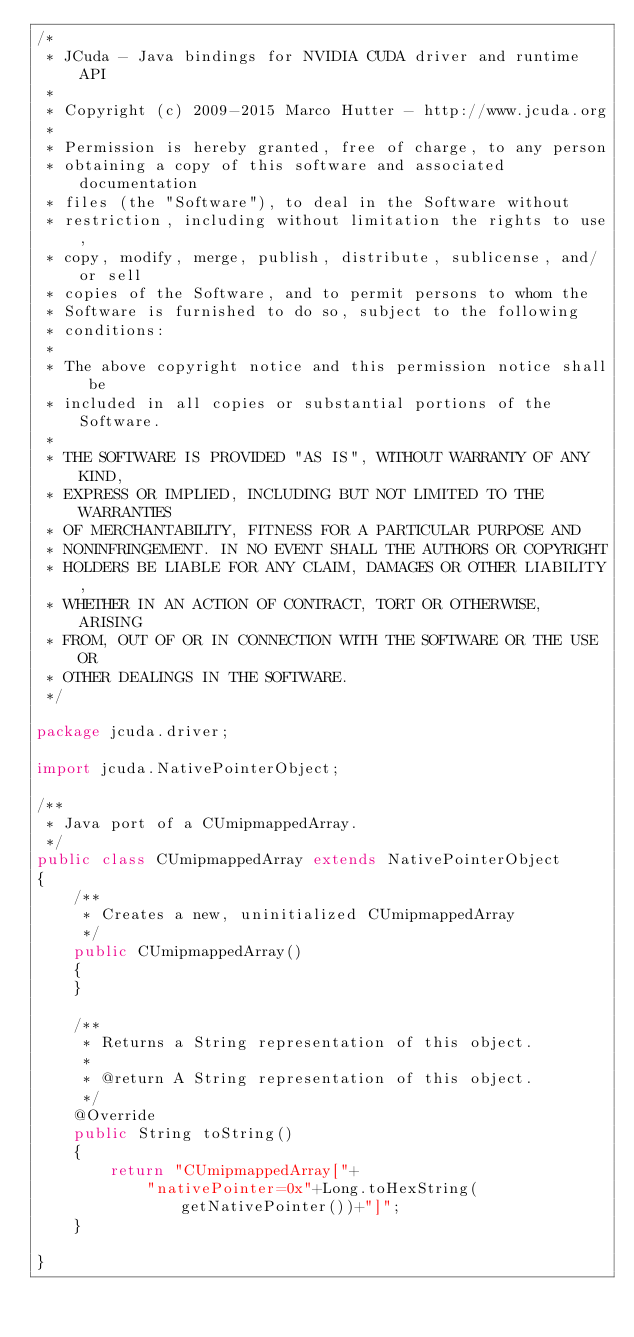<code> <loc_0><loc_0><loc_500><loc_500><_Java_>/*
 * JCuda - Java bindings for NVIDIA CUDA driver and runtime API
 *
 * Copyright (c) 2009-2015 Marco Hutter - http://www.jcuda.org
 *
 * Permission is hereby granted, free of charge, to any person
 * obtaining a copy of this software and associated documentation
 * files (the "Software"), to deal in the Software without
 * restriction, including without limitation the rights to use,
 * copy, modify, merge, publish, distribute, sublicense, and/or sell
 * copies of the Software, and to permit persons to whom the
 * Software is furnished to do so, subject to the following
 * conditions:
 *
 * The above copyright notice and this permission notice shall be
 * included in all copies or substantial portions of the Software.
 *
 * THE SOFTWARE IS PROVIDED "AS IS", WITHOUT WARRANTY OF ANY KIND,
 * EXPRESS OR IMPLIED, INCLUDING BUT NOT LIMITED TO THE WARRANTIES
 * OF MERCHANTABILITY, FITNESS FOR A PARTICULAR PURPOSE AND
 * NONINFRINGEMENT. IN NO EVENT SHALL THE AUTHORS OR COPYRIGHT
 * HOLDERS BE LIABLE FOR ANY CLAIM, DAMAGES OR OTHER LIABILITY,
 * WHETHER IN AN ACTION OF CONTRACT, TORT OR OTHERWISE, ARISING
 * FROM, OUT OF OR IN CONNECTION WITH THE SOFTWARE OR THE USE OR
 * OTHER DEALINGS IN THE SOFTWARE.
 */

package jcuda.driver;

import jcuda.NativePointerObject;

/**
 * Java port of a CUmipmappedArray.
 */
public class CUmipmappedArray extends NativePointerObject
{
    /**
     * Creates a new, uninitialized CUmipmappedArray
     */
    public CUmipmappedArray()
    {
    }

    /**
     * Returns a String representation of this object.
     *
     * @return A String representation of this object.
     */
    @Override
    public String toString()
    {
        return "CUmipmappedArray["+
            "nativePointer=0x"+Long.toHexString(getNativePointer())+"]";
    }

}
</code> 